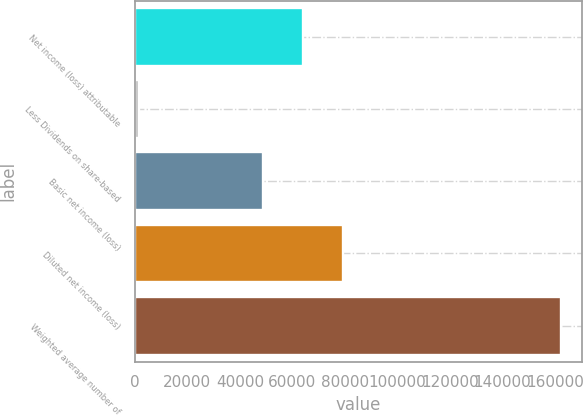Convert chart to OTSL. <chart><loc_0><loc_0><loc_500><loc_500><bar_chart><fcel>Net income (loss) attributable<fcel>Less Dividends on share-based<fcel>Basic net income (loss)<fcel>Diluted net income (loss)<fcel>Weighted average number of<nl><fcel>64069.2<fcel>1631<fcel>48777<fcel>79361.4<fcel>162207<nl></chart> 